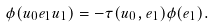Convert formula to latex. <formula><loc_0><loc_0><loc_500><loc_500>\phi ( u _ { 0 } e _ { 1 } u _ { 1 } ) = - \tau ( u _ { 0 } , e _ { 1 } ) \phi ( e _ { 1 } ) .</formula> 